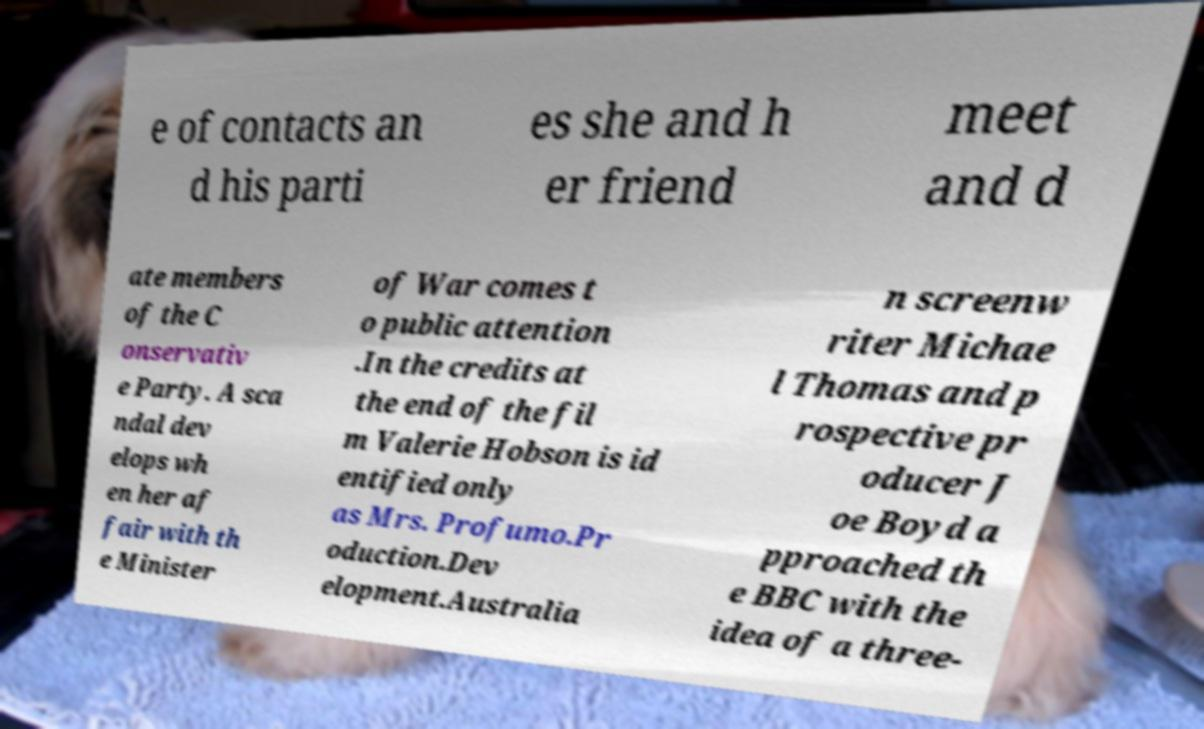Could you extract and type out the text from this image? e of contacts an d his parti es she and h er friend meet and d ate members of the C onservativ e Party. A sca ndal dev elops wh en her af fair with th e Minister of War comes t o public attention .In the credits at the end of the fil m Valerie Hobson is id entified only as Mrs. Profumo.Pr oduction.Dev elopment.Australia n screenw riter Michae l Thomas and p rospective pr oducer J oe Boyd a pproached th e BBC with the idea of a three- 